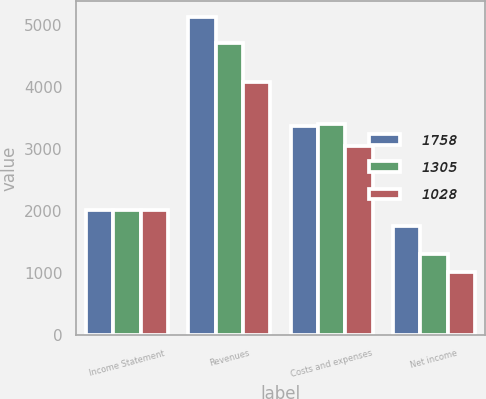Convert chart. <chart><loc_0><loc_0><loc_500><loc_500><stacked_bar_chart><ecel><fcel>Income Statement<fcel>Revenues<fcel>Costs and expenses<fcel>Net income<nl><fcel>1758<fcel>2018<fcel>5129<fcel>3371<fcel>1758<nl><fcel>1305<fcel>2017<fcel>4703<fcel>3398<fcel>1305<nl><fcel>1028<fcel>2016<fcel>4084<fcel>3056<fcel>1028<nl></chart> 